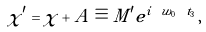Convert formula to latex. <formula><loc_0><loc_0><loc_500><loc_500>\chi ^ { \prime } = \chi + A \equiv M ^ { \prime } e ^ { i \ w _ { 0 } \ t _ { 3 } } \, ,</formula> 